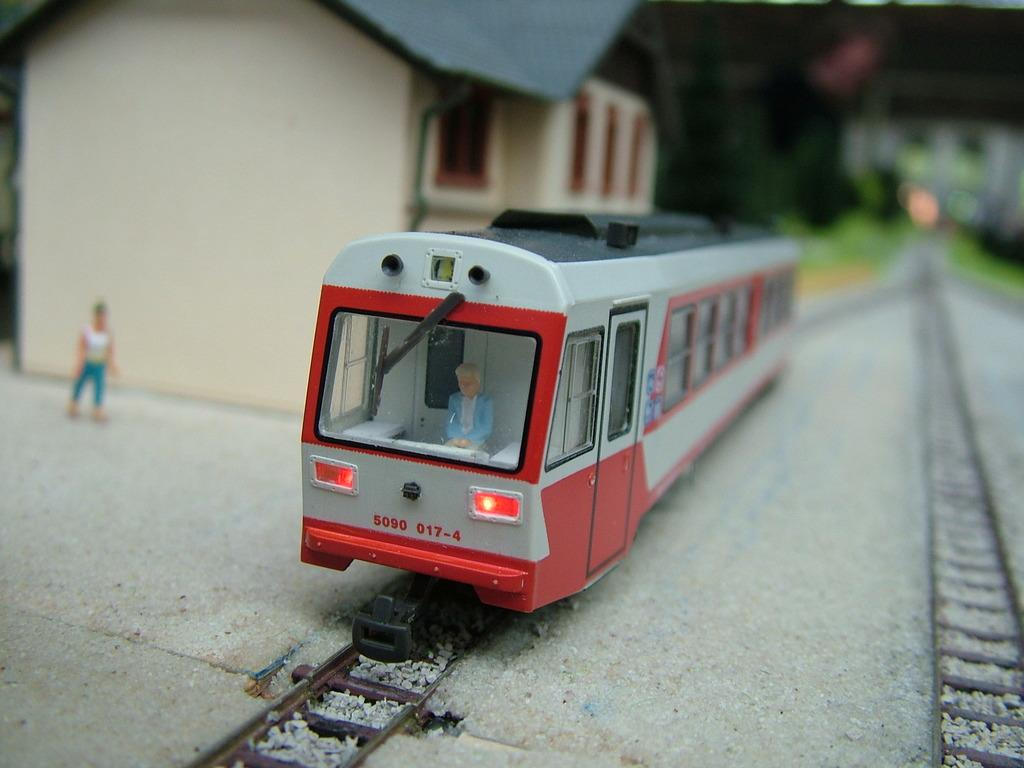What type of toy is present in the image? There is a toy train in the image. What structure can be seen on the left side of the image? There is a house on the left side of the image. What color is the rose held by the man in the image? There is no rose or man present in the image; it only features a toy train and a house. 